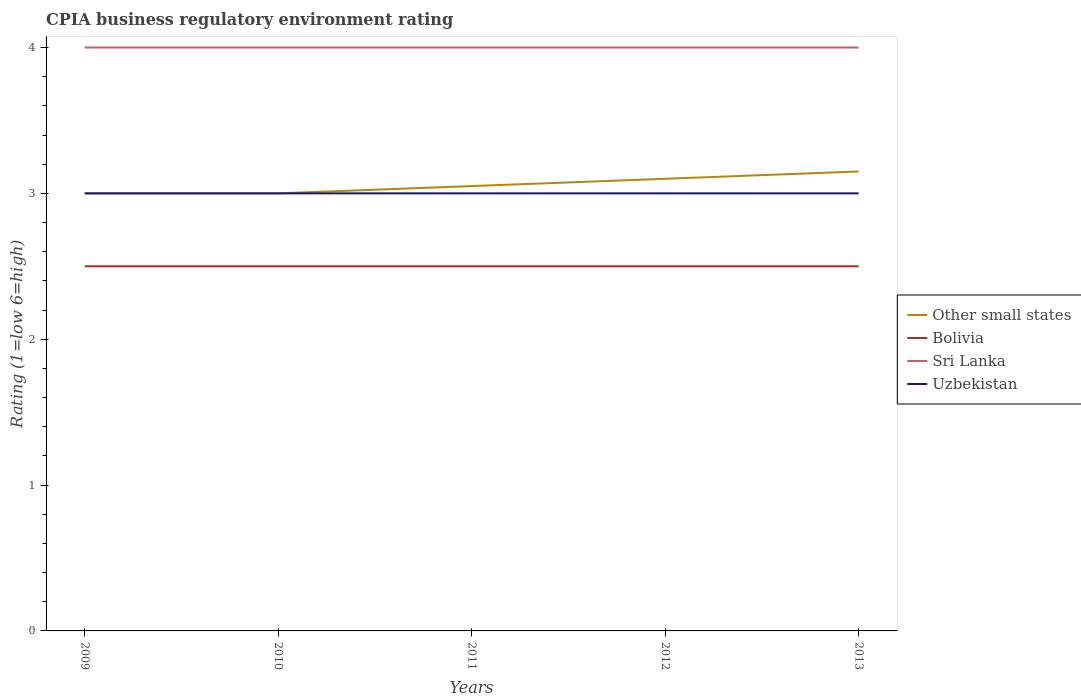Does the line corresponding to Other small states intersect with the line corresponding to Bolivia?
Offer a very short reply. No. Is the number of lines equal to the number of legend labels?
Your answer should be very brief. Yes. What is the total CPIA rating in Uzbekistan in the graph?
Your answer should be very brief. 0. What is the difference between the highest and the second highest CPIA rating in Other small states?
Keep it short and to the point. 0.15. How many lines are there?
Provide a succinct answer. 4. Are the values on the major ticks of Y-axis written in scientific E-notation?
Offer a terse response. No. Does the graph contain grids?
Offer a terse response. No. How are the legend labels stacked?
Keep it short and to the point. Vertical. What is the title of the graph?
Give a very brief answer. CPIA business regulatory environment rating. What is the label or title of the X-axis?
Your response must be concise. Years. What is the label or title of the Y-axis?
Give a very brief answer. Rating (1=low 6=high). What is the Rating (1=low 6=high) in Bolivia in 2009?
Your answer should be very brief. 2.5. What is the Rating (1=low 6=high) of Bolivia in 2010?
Your answer should be very brief. 2.5. What is the Rating (1=low 6=high) in Sri Lanka in 2010?
Offer a very short reply. 4. What is the Rating (1=low 6=high) in Other small states in 2011?
Offer a terse response. 3.05. What is the Rating (1=low 6=high) in Bolivia in 2011?
Your response must be concise. 2.5. What is the Rating (1=low 6=high) in Uzbekistan in 2011?
Give a very brief answer. 3. What is the Rating (1=low 6=high) of Other small states in 2012?
Your response must be concise. 3.1. What is the Rating (1=low 6=high) in Bolivia in 2012?
Your response must be concise. 2.5. What is the Rating (1=low 6=high) in Uzbekistan in 2012?
Provide a succinct answer. 3. What is the Rating (1=low 6=high) of Other small states in 2013?
Provide a short and direct response. 3.15. What is the Rating (1=low 6=high) of Uzbekistan in 2013?
Your response must be concise. 3. Across all years, what is the maximum Rating (1=low 6=high) of Other small states?
Your answer should be very brief. 3.15. Across all years, what is the maximum Rating (1=low 6=high) of Bolivia?
Your answer should be compact. 2.5. Across all years, what is the minimum Rating (1=low 6=high) in Other small states?
Your response must be concise. 3. What is the total Rating (1=low 6=high) of Other small states in the graph?
Keep it short and to the point. 15.3. What is the total Rating (1=low 6=high) of Sri Lanka in the graph?
Provide a short and direct response. 20. What is the total Rating (1=low 6=high) of Uzbekistan in the graph?
Keep it short and to the point. 15. What is the difference between the Rating (1=low 6=high) in Uzbekistan in 2009 and that in 2010?
Provide a short and direct response. 0. What is the difference between the Rating (1=low 6=high) in Other small states in 2009 and that in 2011?
Keep it short and to the point. -0.05. What is the difference between the Rating (1=low 6=high) of Sri Lanka in 2009 and that in 2011?
Ensure brevity in your answer.  0. What is the difference between the Rating (1=low 6=high) of Uzbekistan in 2009 and that in 2011?
Ensure brevity in your answer.  0. What is the difference between the Rating (1=low 6=high) of Other small states in 2009 and that in 2012?
Make the answer very short. -0.1. What is the difference between the Rating (1=low 6=high) of Bolivia in 2009 and that in 2012?
Provide a short and direct response. 0. What is the difference between the Rating (1=low 6=high) in Other small states in 2009 and that in 2013?
Keep it short and to the point. -0.15. What is the difference between the Rating (1=low 6=high) in Bolivia in 2009 and that in 2013?
Keep it short and to the point. 0. What is the difference between the Rating (1=low 6=high) of Uzbekistan in 2009 and that in 2013?
Give a very brief answer. 0. What is the difference between the Rating (1=low 6=high) in Sri Lanka in 2010 and that in 2011?
Offer a terse response. 0. What is the difference between the Rating (1=low 6=high) of Uzbekistan in 2010 and that in 2011?
Ensure brevity in your answer.  0. What is the difference between the Rating (1=low 6=high) of Bolivia in 2010 and that in 2012?
Ensure brevity in your answer.  0. What is the difference between the Rating (1=low 6=high) of Sri Lanka in 2010 and that in 2012?
Your answer should be compact. 0. What is the difference between the Rating (1=low 6=high) of Uzbekistan in 2010 and that in 2012?
Provide a short and direct response. 0. What is the difference between the Rating (1=low 6=high) in Bolivia in 2010 and that in 2013?
Provide a short and direct response. 0. What is the difference between the Rating (1=low 6=high) in Sri Lanka in 2010 and that in 2013?
Offer a terse response. 0. What is the difference between the Rating (1=low 6=high) of Uzbekistan in 2010 and that in 2013?
Your answer should be very brief. 0. What is the difference between the Rating (1=low 6=high) of Other small states in 2011 and that in 2012?
Give a very brief answer. -0.05. What is the difference between the Rating (1=low 6=high) of Bolivia in 2011 and that in 2012?
Make the answer very short. 0. What is the difference between the Rating (1=low 6=high) of Bolivia in 2011 and that in 2013?
Give a very brief answer. 0. What is the difference between the Rating (1=low 6=high) of Sri Lanka in 2011 and that in 2013?
Your answer should be compact. 0. What is the difference between the Rating (1=low 6=high) in Sri Lanka in 2012 and that in 2013?
Offer a very short reply. 0. What is the difference between the Rating (1=low 6=high) in Other small states in 2009 and the Rating (1=low 6=high) in Bolivia in 2010?
Offer a very short reply. 0.5. What is the difference between the Rating (1=low 6=high) of Bolivia in 2009 and the Rating (1=low 6=high) of Uzbekistan in 2010?
Provide a short and direct response. -0.5. What is the difference between the Rating (1=low 6=high) in Sri Lanka in 2009 and the Rating (1=low 6=high) in Uzbekistan in 2010?
Your answer should be compact. 1. What is the difference between the Rating (1=low 6=high) in Other small states in 2009 and the Rating (1=low 6=high) in Bolivia in 2011?
Your answer should be compact. 0.5. What is the difference between the Rating (1=low 6=high) of Other small states in 2009 and the Rating (1=low 6=high) of Uzbekistan in 2011?
Ensure brevity in your answer.  0. What is the difference between the Rating (1=low 6=high) of Sri Lanka in 2009 and the Rating (1=low 6=high) of Uzbekistan in 2011?
Make the answer very short. 1. What is the difference between the Rating (1=low 6=high) in Other small states in 2009 and the Rating (1=low 6=high) in Sri Lanka in 2012?
Offer a terse response. -1. What is the difference between the Rating (1=low 6=high) in Other small states in 2009 and the Rating (1=low 6=high) in Uzbekistan in 2012?
Provide a succinct answer. 0. What is the difference between the Rating (1=low 6=high) of Bolivia in 2009 and the Rating (1=low 6=high) of Uzbekistan in 2012?
Your answer should be compact. -0.5. What is the difference between the Rating (1=low 6=high) of Sri Lanka in 2009 and the Rating (1=low 6=high) of Uzbekistan in 2012?
Provide a succinct answer. 1. What is the difference between the Rating (1=low 6=high) in Other small states in 2009 and the Rating (1=low 6=high) in Bolivia in 2013?
Provide a short and direct response. 0.5. What is the difference between the Rating (1=low 6=high) in Other small states in 2009 and the Rating (1=low 6=high) in Sri Lanka in 2013?
Your answer should be very brief. -1. What is the difference between the Rating (1=low 6=high) of Bolivia in 2009 and the Rating (1=low 6=high) of Sri Lanka in 2013?
Ensure brevity in your answer.  -1.5. What is the difference between the Rating (1=low 6=high) of Bolivia in 2009 and the Rating (1=low 6=high) of Uzbekistan in 2013?
Keep it short and to the point. -0.5. What is the difference between the Rating (1=low 6=high) in Other small states in 2010 and the Rating (1=low 6=high) in Bolivia in 2011?
Offer a terse response. 0.5. What is the difference between the Rating (1=low 6=high) of Bolivia in 2010 and the Rating (1=low 6=high) of Sri Lanka in 2011?
Offer a terse response. -1.5. What is the difference between the Rating (1=low 6=high) in Bolivia in 2010 and the Rating (1=low 6=high) in Uzbekistan in 2011?
Make the answer very short. -0.5. What is the difference between the Rating (1=low 6=high) in Other small states in 2010 and the Rating (1=low 6=high) in Bolivia in 2012?
Offer a terse response. 0.5. What is the difference between the Rating (1=low 6=high) in Other small states in 2010 and the Rating (1=low 6=high) in Uzbekistan in 2012?
Your answer should be compact. 0. What is the difference between the Rating (1=low 6=high) in Sri Lanka in 2010 and the Rating (1=low 6=high) in Uzbekistan in 2012?
Your answer should be very brief. 1. What is the difference between the Rating (1=low 6=high) of Other small states in 2010 and the Rating (1=low 6=high) of Sri Lanka in 2013?
Provide a succinct answer. -1. What is the difference between the Rating (1=low 6=high) in Other small states in 2010 and the Rating (1=low 6=high) in Uzbekistan in 2013?
Your answer should be very brief. 0. What is the difference between the Rating (1=low 6=high) of Bolivia in 2010 and the Rating (1=low 6=high) of Sri Lanka in 2013?
Ensure brevity in your answer.  -1.5. What is the difference between the Rating (1=low 6=high) in Sri Lanka in 2010 and the Rating (1=low 6=high) in Uzbekistan in 2013?
Your response must be concise. 1. What is the difference between the Rating (1=low 6=high) in Other small states in 2011 and the Rating (1=low 6=high) in Bolivia in 2012?
Provide a short and direct response. 0.55. What is the difference between the Rating (1=low 6=high) of Other small states in 2011 and the Rating (1=low 6=high) of Sri Lanka in 2012?
Your response must be concise. -0.95. What is the difference between the Rating (1=low 6=high) of Bolivia in 2011 and the Rating (1=low 6=high) of Sri Lanka in 2012?
Make the answer very short. -1.5. What is the difference between the Rating (1=low 6=high) in Bolivia in 2011 and the Rating (1=low 6=high) in Uzbekistan in 2012?
Ensure brevity in your answer.  -0.5. What is the difference between the Rating (1=low 6=high) in Sri Lanka in 2011 and the Rating (1=low 6=high) in Uzbekistan in 2012?
Keep it short and to the point. 1. What is the difference between the Rating (1=low 6=high) of Other small states in 2011 and the Rating (1=low 6=high) of Bolivia in 2013?
Your response must be concise. 0.55. What is the difference between the Rating (1=low 6=high) in Other small states in 2011 and the Rating (1=low 6=high) in Sri Lanka in 2013?
Provide a short and direct response. -0.95. What is the difference between the Rating (1=low 6=high) in Other small states in 2011 and the Rating (1=low 6=high) in Uzbekistan in 2013?
Your answer should be compact. 0.05. What is the difference between the Rating (1=low 6=high) of Sri Lanka in 2011 and the Rating (1=low 6=high) of Uzbekistan in 2013?
Provide a short and direct response. 1. What is the difference between the Rating (1=low 6=high) of Other small states in 2012 and the Rating (1=low 6=high) of Bolivia in 2013?
Make the answer very short. 0.6. What is the difference between the Rating (1=low 6=high) in Other small states in 2012 and the Rating (1=low 6=high) in Uzbekistan in 2013?
Provide a short and direct response. 0.1. What is the difference between the Rating (1=low 6=high) in Bolivia in 2012 and the Rating (1=low 6=high) in Uzbekistan in 2013?
Provide a succinct answer. -0.5. What is the difference between the Rating (1=low 6=high) of Sri Lanka in 2012 and the Rating (1=low 6=high) of Uzbekistan in 2013?
Offer a very short reply. 1. What is the average Rating (1=low 6=high) of Other small states per year?
Ensure brevity in your answer.  3.06. In the year 2009, what is the difference between the Rating (1=low 6=high) of Other small states and Rating (1=low 6=high) of Bolivia?
Offer a very short reply. 0.5. In the year 2009, what is the difference between the Rating (1=low 6=high) in Bolivia and Rating (1=low 6=high) in Sri Lanka?
Your response must be concise. -1.5. In the year 2010, what is the difference between the Rating (1=low 6=high) in Other small states and Rating (1=low 6=high) in Uzbekistan?
Your answer should be compact. 0. In the year 2010, what is the difference between the Rating (1=low 6=high) of Bolivia and Rating (1=low 6=high) of Sri Lanka?
Your answer should be compact. -1.5. In the year 2011, what is the difference between the Rating (1=low 6=high) in Other small states and Rating (1=low 6=high) in Bolivia?
Your answer should be compact. 0.55. In the year 2011, what is the difference between the Rating (1=low 6=high) of Other small states and Rating (1=low 6=high) of Sri Lanka?
Make the answer very short. -0.95. In the year 2011, what is the difference between the Rating (1=low 6=high) in Other small states and Rating (1=low 6=high) in Uzbekistan?
Give a very brief answer. 0.05. In the year 2012, what is the difference between the Rating (1=low 6=high) of Other small states and Rating (1=low 6=high) of Bolivia?
Provide a succinct answer. 0.6. In the year 2012, what is the difference between the Rating (1=low 6=high) of Other small states and Rating (1=low 6=high) of Sri Lanka?
Provide a short and direct response. -0.9. In the year 2012, what is the difference between the Rating (1=low 6=high) of Other small states and Rating (1=low 6=high) of Uzbekistan?
Offer a very short reply. 0.1. In the year 2013, what is the difference between the Rating (1=low 6=high) of Other small states and Rating (1=low 6=high) of Bolivia?
Ensure brevity in your answer.  0.65. In the year 2013, what is the difference between the Rating (1=low 6=high) of Other small states and Rating (1=low 6=high) of Sri Lanka?
Give a very brief answer. -0.85. In the year 2013, what is the difference between the Rating (1=low 6=high) of Other small states and Rating (1=low 6=high) of Uzbekistan?
Your answer should be very brief. 0.15. In the year 2013, what is the difference between the Rating (1=low 6=high) in Bolivia and Rating (1=low 6=high) in Uzbekistan?
Offer a terse response. -0.5. What is the ratio of the Rating (1=low 6=high) in Sri Lanka in 2009 to that in 2010?
Offer a very short reply. 1. What is the ratio of the Rating (1=low 6=high) of Uzbekistan in 2009 to that in 2010?
Your answer should be very brief. 1. What is the ratio of the Rating (1=low 6=high) of Other small states in 2009 to that in 2011?
Offer a terse response. 0.98. What is the ratio of the Rating (1=low 6=high) of Bolivia in 2009 to that in 2011?
Offer a terse response. 1. What is the ratio of the Rating (1=low 6=high) in Uzbekistan in 2009 to that in 2011?
Offer a very short reply. 1. What is the ratio of the Rating (1=low 6=high) of Other small states in 2009 to that in 2012?
Offer a terse response. 0.97. What is the ratio of the Rating (1=low 6=high) of Sri Lanka in 2009 to that in 2012?
Provide a short and direct response. 1. What is the ratio of the Rating (1=low 6=high) in Uzbekistan in 2009 to that in 2012?
Ensure brevity in your answer.  1. What is the ratio of the Rating (1=low 6=high) in Other small states in 2009 to that in 2013?
Provide a succinct answer. 0.95. What is the ratio of the Rating (1=low 6=high) of Bolivia in 2009 to that in 2013?
Keep it short and to the point. 1. What is the ratio of the Rating (1=low 6=high) of Sri Lanka in 2009 to that in 2013?
Keep it short and to the point. 1. What is the ratio of the Rating (1=low 6=high) of Uzbekistan in 2009 to that in 2013?
Give a very brief answer. 1. What is the ratio of the Rating (1=low 6=high) of Other small states in 2010 to that in 2011?
Make the answer very short. 0.98. What is the ratio of the Rating (1=low 6=high) in Bolivia in 2010 to that in 2011?
Offer a very short reply. 1. What is the ratio of the Rating (1=low 6=high) of Sri Lanka in 2010 to that in 2011?
Keep it short and to the point. 1. What is the ratio of the Rating (1=low 6=high) in Uzbekistan in 2010 to that in 2011?
Ensure brevity in your answer.  1. What is the ratio of the Rating (1=low 6=high) in Other small states in 2010 to that in 2012?
Give a very brief answer. 0.97. What is the ratio of the Rating (1=low 6=high) in Bolivia in 2010 to that in 2012?
Keep it short and to the point. 1. What is the ratio of the Rating (1=low 6=high) of Sri Lanka in 2010 to that in 2012?
Keep it short and to the point. 1. What is the ratio of the Rating (1=low 6=high) of Uzbekistan in 2010 to that in 2012?
Your answer should be very brief. 1. What is the ratio of the Rating (1=low 6=high) in Other small states in 2010 to that in 2013?
Give a very brief answer. 0.95. What is the ratio of the Rating (1=low 6=high) of Uzbekistan in 2010 to that in 2013?
Provide a short and direct response. 1. What is the ratio of the Rating (1=low 6=high) of Other small states in 2011 to that in 2012?
Your answer should be compact. 0.98. What is the ratio of the Rating (1=low 6=high) in Bolivia in 2011 to that in 2012?
Keep it short and to the point. 1. What is the ratio of the Rating (1=low 6=high) in Other small states in 2011 to that in 2013?
Ensure brevity in your answer.  0.97. What is the ratio of the Rating (1=low 6=high) of Uzbekistan in 2011 to that in 2013?
Your response must be concise. 1. What is the ratio of the Rating (1=low 6=high) in Other small states in 2012 to that in 2013?
Your answer should be compact. 0.98. What is the ratio of the Rating (1=low 6=high) of Sri Lanka in 2012 to that in 2013?
Your answer should be compact. 1. What is the difference between the highest and the second highest Rating (1=low 6=high) in Bolivia?
Provide a succinct answer. 0. What is the difference between the highest and the lowest Rating (1=low 6=high) of Other small states?
Give a very brief answer. 0.15. What is the difference between the highest and the lowest Rating (1=low 6=high) of Sri Lanka?
Provide a succinct answer. 0. What is the difference between the highest and the lowest Rating (1=low 6=high) in Uzbekistan?
Provide a succinct answer. 0. 